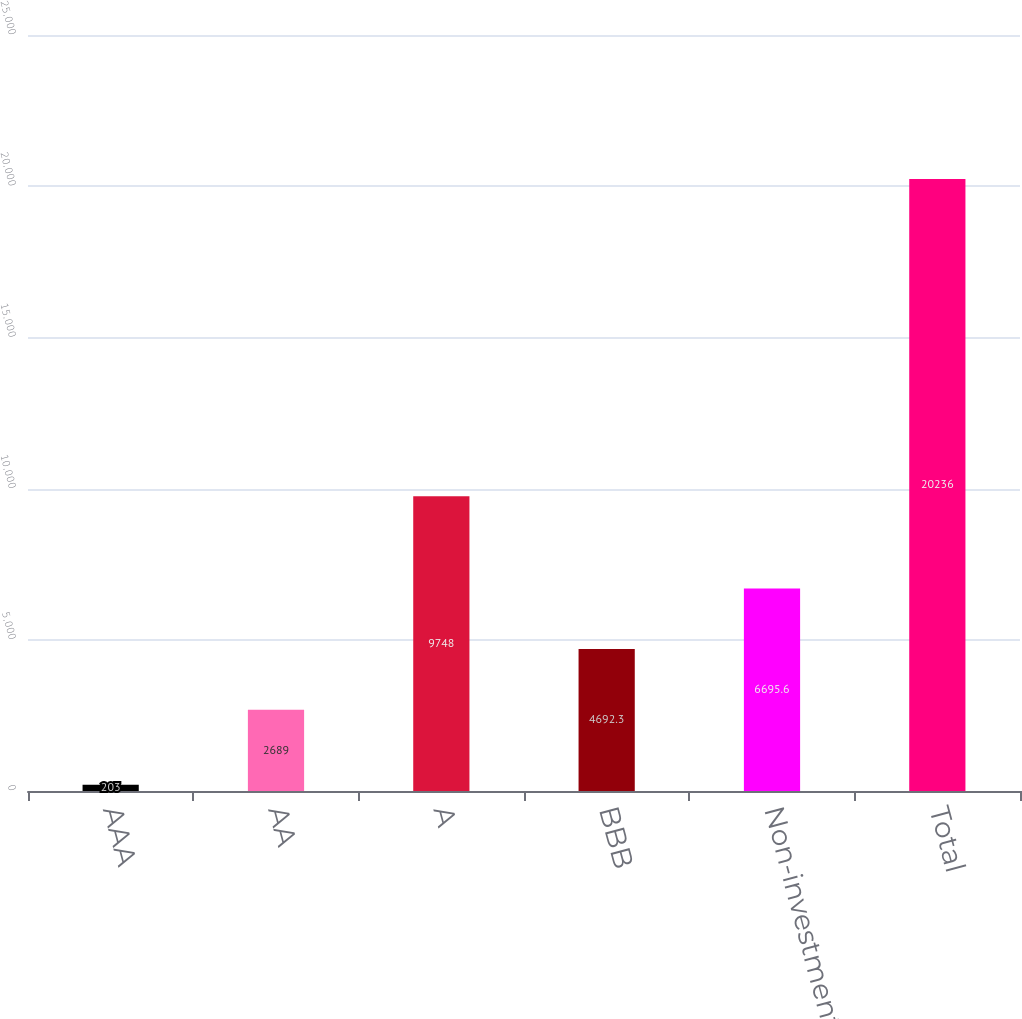<chart> <loc_0><loc_0><loc_500><loc_500><bar_chart><fcel>AAA<fcel>AA<fcel>A<fcel>BBB<fcel>Non-investment grade<fcel>Total<nl><fcel>203<fcel>2689<fcel>9748<fcel>4692.3<fcel>6695.6<fcel>20236<nl></chart> 